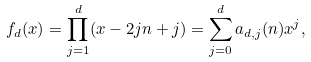<formula> <loc_0><loc_0><loc_500><loc_500>f _ { d } ( x ) = \prod _ { j = 1 } ^ { d } ( x - 2 j n + j ) = \sum _ { j = 0 } ^ { d } a _ { d , j } ( n ) x ^ { j } ,</formula> 